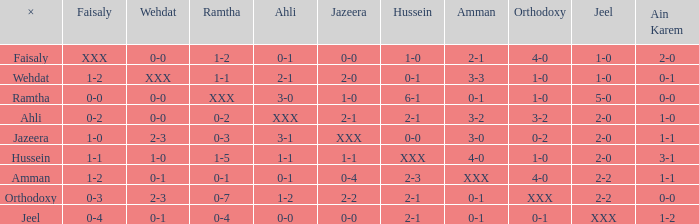What is ramtha when jeel is 1-0 and hussein is 1-0? 1-2. 